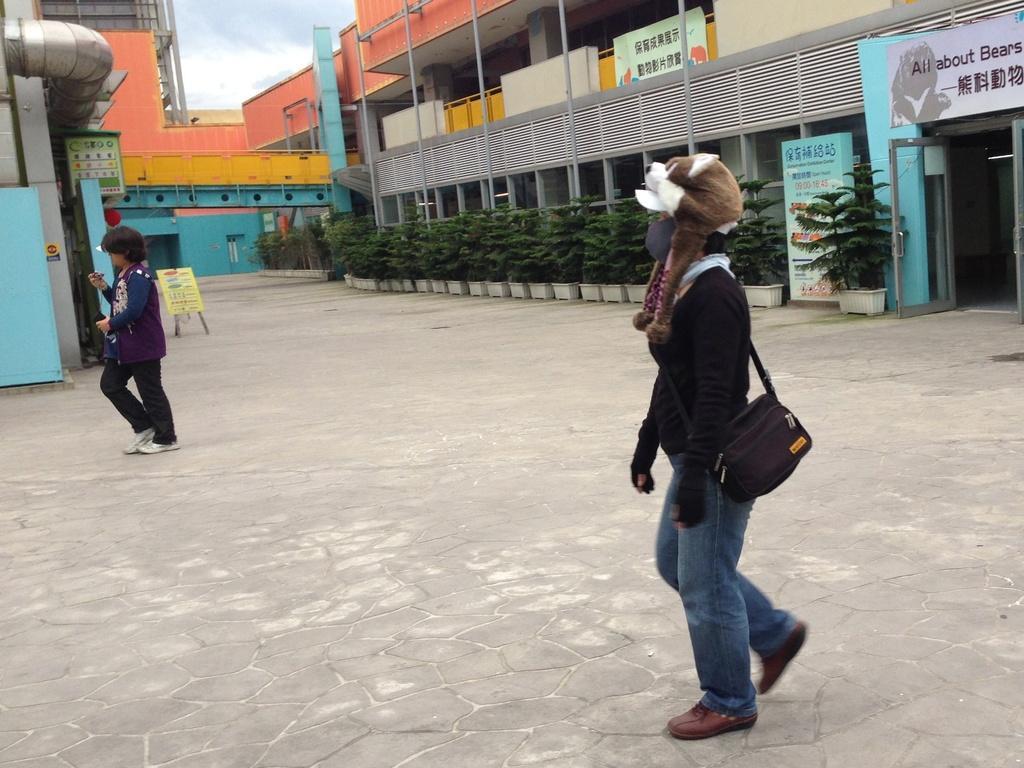How would you summarize this image in a sentence or two? In this image we can see two women walking on the ground. One woman is wearing a bag. On the left side of the image we can see a board placed on stands and some pipes. In the center of the image we can see group of plants in pots. At the top of the image we can see building with some poles, boards with text and the sky. 